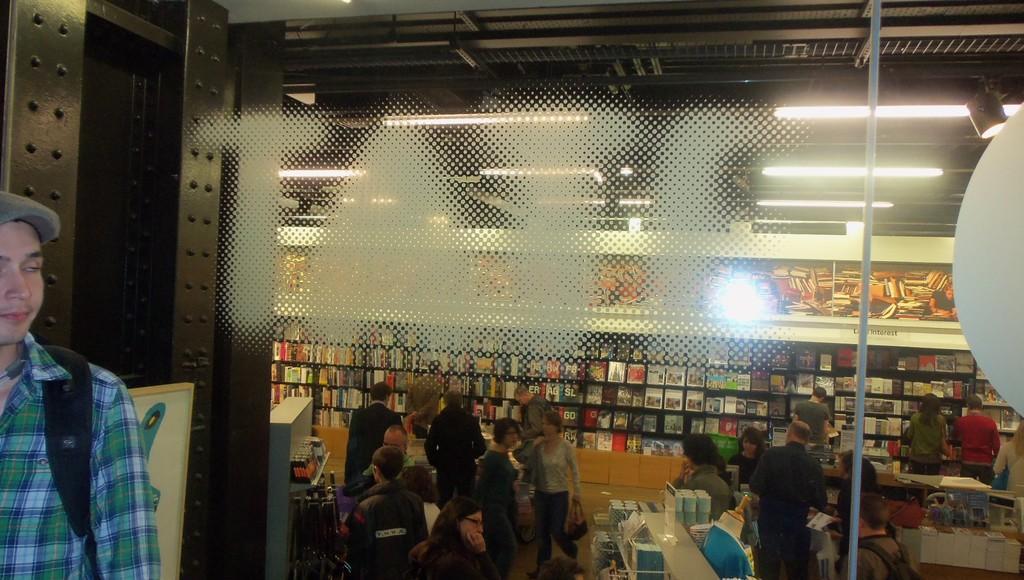In one or two sentences, can you explain what this image depicts? In this image, I can see a person standing. This looks like a glass door. I think this is a bookstore. There are groups of people standing. I can see the books, which are placed in the rack. These are the lights. On the right side of the image, that looks like a board. 